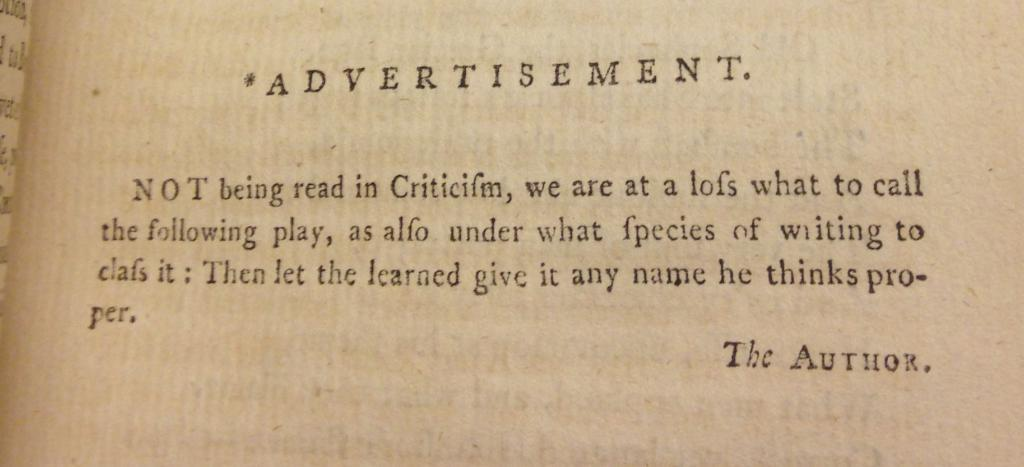<image>
Relay a brief, clear account of the picture shown. A book is open to a page about the author titled Advertisement. 